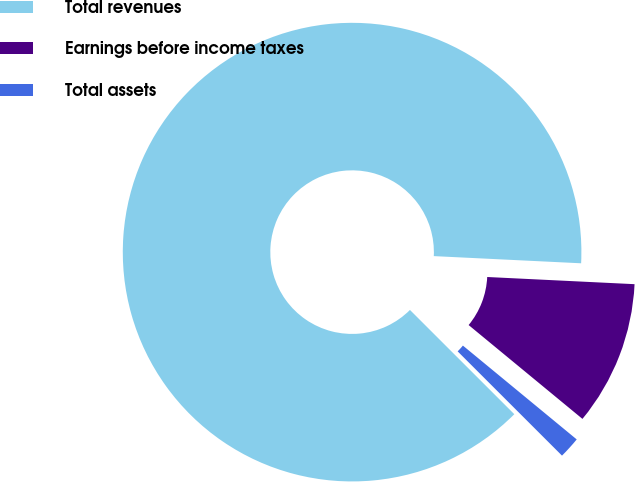Convert chart to OTSL. <chart><loc_0><loc_0><loc_500><loc_500><pie_chart><fcel>Total revenues<fcel>Earnings before income taxes<fcel>Total assets<nl><fcel>88.29%<fcel>10.2%<fcel>1.52%<nl></chart> 